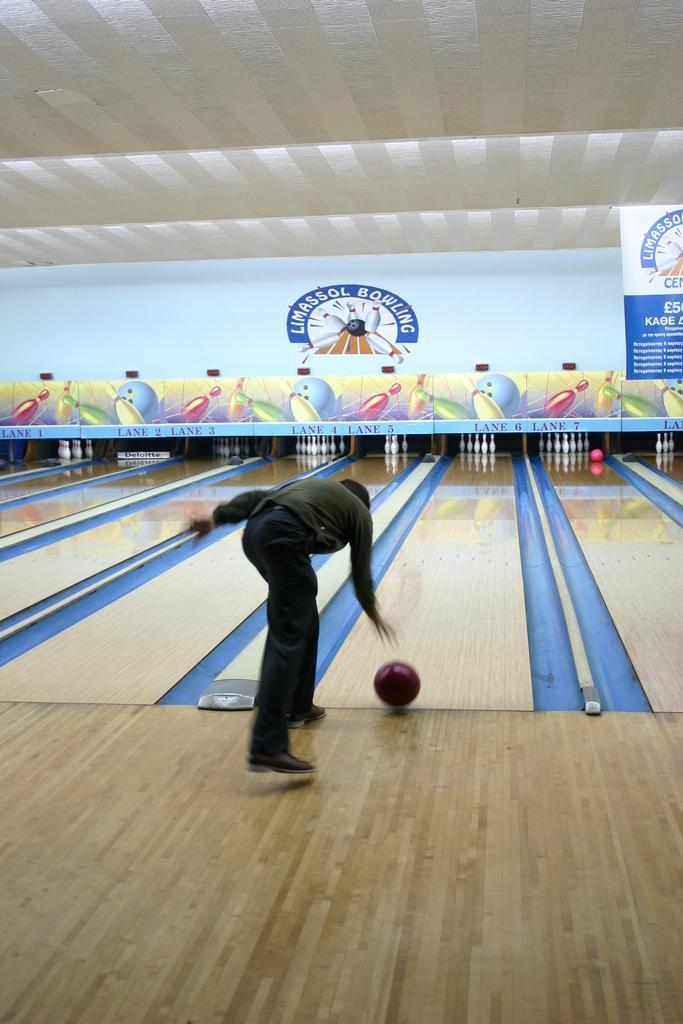Describe this image in one or two sentences. In the image there is ten pin bowling game and there is a person in the foreground, he is throwing a ball. 